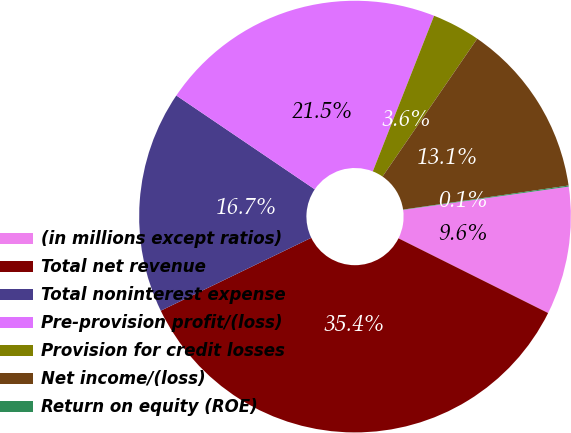Convert chart to OTSL. <chart><loc_0><loc_0><loc_500><loc_500><pie_chart><fcel>(in millions except ratios)<fcel>Total net revenue<fcel>Total noninterest expense<fcel>Pre-provision profit/(loss)<fcel>Provision for credit losses<fcel>Net income/(loss)<fcel>Return on equity (ROE)<nl><fcel>9.59%<fcel>35.45%<fcel>16.66%<fcel>21.49%<fcel>3.61%<fcel>13.12%<fcel>0.08%<nl></chart> 